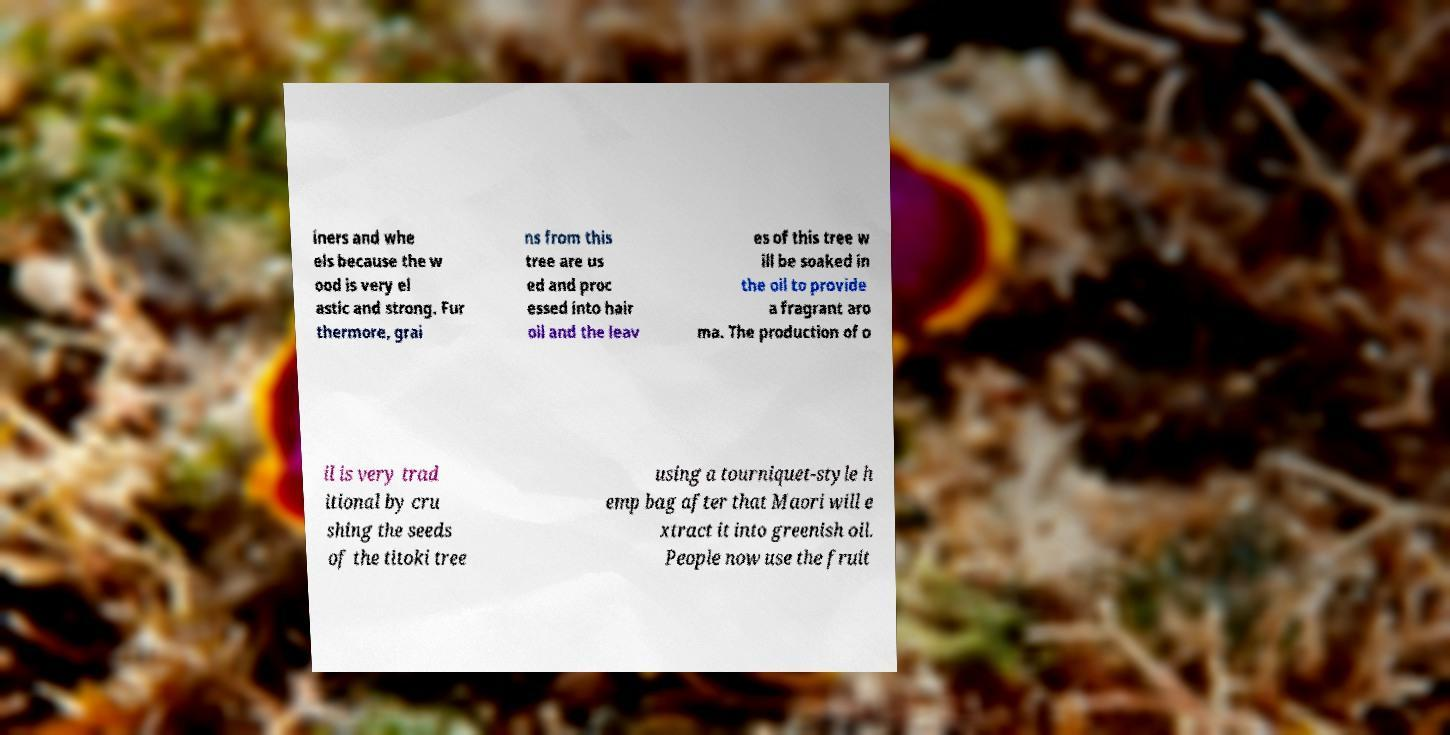Please read and relay the text visible in this image. What does it say? iners and whe els because the w ood is very el astic and strong. Fur thermore, grai ns from this tree are us ed and proc essed into hair oil and the leav es of this tree w ill be soaked in the oil to provide a fragrant aro ma. The production of o il is very trad itional by cru shing the seeds of the titoki tree using a tourniquet-style h emp bag after that Maori will e xtract it into greenish oil. People now use the fruit 